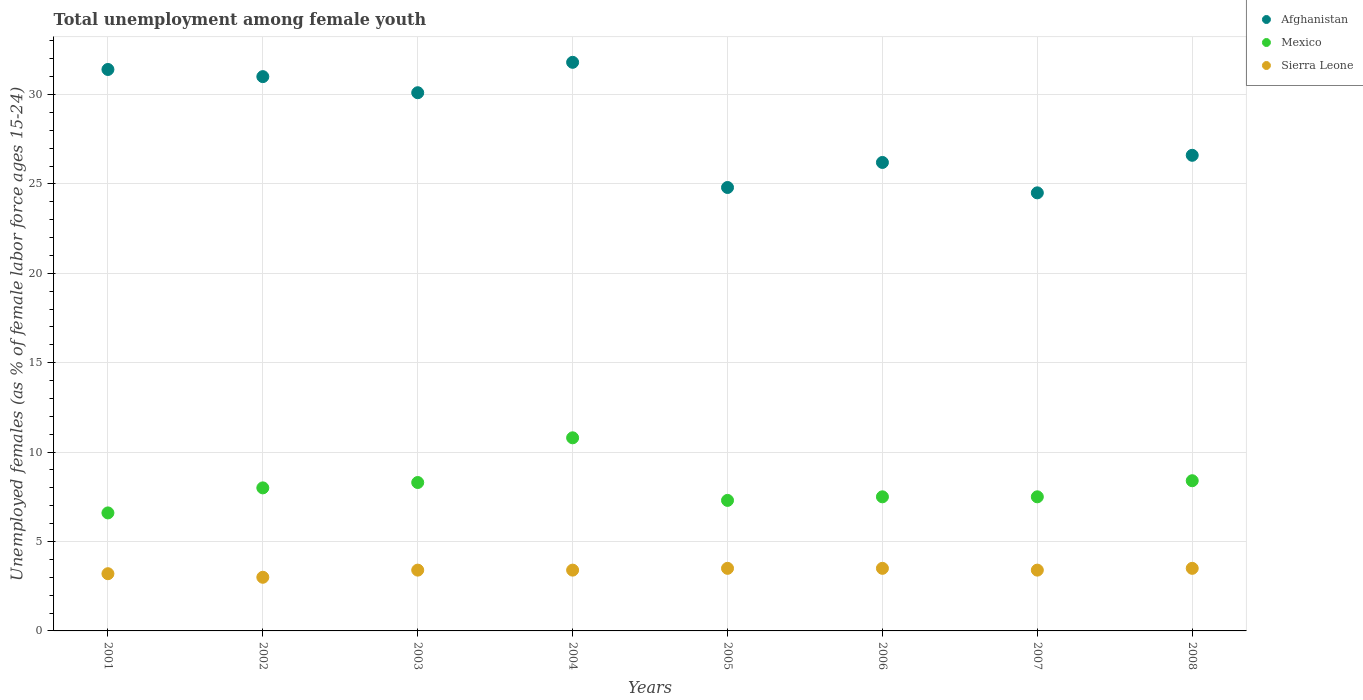Is the number of dotlines equal to the number of legend labels?
Offer a terse response. Yes. What is the percentage of unemployed females in in Sierra Leone in 2005?
Your answer should be very brief. 3.5. Across all years, what is the maximum percentage of unemployed females in in Mexico?
Make the answer very short. 10.8. Across all years, what is the minimum percentage of unemployed females in in Afghanistan?
Ensure brevity in your answer.  24.5. In which year was the percentage of unemployed females in in Sierra Leone minimum?
Make the answer very short. 2002. What is the total percentage of unemployed females in in Afghanistan in the graph?
Make the answer very short. 226.4. What is the difference between the percentage of unemployed females in in Afghanistan in 2007 and that in 2008?
Make the answer very short. -2.1. What is the difference between the percentage of unemployed females in in Mexico in 2003 and the percentage of unemployed females in in Afghanistan in 2001?
Give a very brief answer. -23.1. What is the average percentage of unemployed females in in Mexico per year?
Your answer should be very brief. 8.05. In the year 2007, what is the difference between the percentage of unemployed females in in Mexico and percentage of unemployed females in in Afghanistan?
Keep it short and to the point. -17. In how many years, is the percentage of unemployed females in in Afghanistan greater than 22 %?
Your answer should be compact. 8. What is the ratio of the percentage of unemployed females in in Afghanistan in 2004 to that in 2006?
Provide a succinct answer. 1.21. What is the difference between the highest and the second highest percentage of unemployed females in in Afghanistan?
Give a very brief answer. 0.4. What is the difference between the highest and the lowest percentage of unemployed females in in Sierra Leone?
Your response must be concise. 0.5. Is it the case that in every year, the sum of the percentage of unemployed females in in Afghanistan and percentage of unemployed females in in Sierra Leone  is greater than the percentage of unemployed females in in Mexico?
Keep it short and to the point. Yes. Does the percentage of unemployed females in in Mexico monotonically increase over the years?
Provide a succinct answer. No. Is the percentage of unemployed females in in Mexico strictly less than the percentage of unemployed females in in Afghanistan over the years?
Ensure brevity in your answer.  Yes. How many dotlines are there?
Make the answer very short. 3. How many years are there in the graph?
Make the answer very short. 8. What is the difference between two consecutive major ticks on the Y-axis?
Your answer should be compact. 5. Where does the legend appear in the graph?
Make the answer very short. Top right. How many legend labels are there?
Give a very brief answer. 3. What is the title of the graph?
Give a very brief answer. Total unemployment among female youth. What is the label or title of the X-axis?
Provide a succinct answer. Years. What is the label or title of the Y-axis?
Make the answer very short. Unemployed females (as % of female labor force ages 15-24). What is the Unemployed females (as % of female labor force ages 15-24) in Afghanistan in 2001?
Provide a short and direct response. 31.4. What is the Unemployed females (as % of female labor force ages 15-24) of Mexico in 2001?
Make the answer very short. 6.6. What is the Unemployed females (as % of female labor force ages 15-24) of Sierra Leone in 2001?
Your answer should be compact. 3.2. What is the Unemployed females (as % of female labor force ages 15-24) of Afghanistan in 2002?
Keep it short and to the point. 31. What is the Unemployed females (as % of female labor force ages 15-24) in Afghanistan in 2003?
Your answer should be compact. 30.1. What is the Unemployed females (as % of female labor force ages 15-24) in Mexico in 2003?
Offer a very short reply. 8.3. What is the Unemployed females (as % of female labor force ages 15-24) in Sierra Leone in 2003?
Offer a terse response. 3.4. What is the Unemployed females (as % of female labor force ages 15-24) of Afghanistan in 2004?
Your response must be concise. 31.8. What is the Unemployed females (as % of female labor force ages 15-24) of Mexico in 2004?
Ensure brevity in your answer.  10.8. What is the Unemployed females (as % of female labor force ages 15-24) of Sierra Leone in 2004?
Ensure brevity in your answer.  3.4. What is the Unemployed females (as % of female labor force ages 15-24) in Afghanistan in 2005?
Make the answer very short. 24.8. What is the Unemployed females (as % of female labor force ages 15-24) of Mexico in 2005?
Make the answer very short. 7.3. What is the Unemployed females (as % of female labor force ages 15-24) in Sierra Leone in 2005?
Give a very brief answer. 3.5. What is the Unemployed females (as % of female labor force ages 15-24) of Afghanistan in 2006?
Your answer should be very brief. 26.2. What is the Unemployed females (as % of female labor force ages 15-24) of Mexico in 2006?
Give a very brief answer. 7.5. What is the Unemployed females (as % of female labor force ages 15-24) of Afghanistan in 2007?
Give a very brief answer. 24.5. What is the Unemployed females (as % of female labor force ages 15-24) of Mexico in 2007?
Make the answer very short. 7.5. What is the Unemployed females (as % of female labor force ages 15-24) of Sierra Leone in 2007?
Keep it short and to the point. 3.4. What is the Unemployed females (as % of female labor force ages 15-24) of Afghanistan in 2008?
Ensure brevity in your answer.  26.6. What is the Unemployed females (as % of female labor force ages 15-24) in Mexico in 2008?
Ensure brevity in your answer.  8.4. What is the Unemployed females (as % of female labor force ages 15-24) in Sierra Leone in 2008?
Your response must be concise. 3.5. Across all years, what is the maximum Unemployed females (as % of female labor force ages 15-24) of Afghanistan?
Provide a short and direct response. 31.8. Across all years, what is the maximum Unemployed females (as % of female labor force ages 15-24) in Mexico?
Provide a succinct answer. 10.8. Across all years, what is the maximum Unemployed females (as % of female labor force ages 15-24) of Sierra Leone?
Provide a succinct answer. 3.5. Across all years, what is the minimum Unemployed females (as % of female labor force ages 15-24) of Mexico?
Your answer should be very brief. 6.6. What is the total Unemployed females (as % of female labor force ages 15-24) of Afghanistan in the graph?
Your answer should be compact. 226.4. What is the total Unemployed females (as % of female labor force ages 15-24) of Mexico in the graph?
Offer a very short reply. 64.4. What is the total Unemployed females (as % of female labor force ages 15-24) in Sierra Leone in the graph?
Provide a short and direct response. 26.9. What is the difference between the Unemployed females (as % of female labor force ages 15-24) in Mexico in 2001 and that in 2002?
Your answer should be compact. -1.4. What is the difference between the Unemployed females (as % of female labor force ages 15-24) in Sierra Leone in 2001 and that in 2002?
Provide a short and direct response. 0.2. What is the difference between the Unemployed females (as % of female labor force ages 15-24) in Afghanistan in 2001 and that in 2003?
Provide a short and direct response. 1.3. What is the difference between the Unemployed females (as % of female labor force ages 15-24) of Sierra Leone in 2001 and that in 2003?
Offer a terse response. -0.2. What is the difference between the Unemployed females (as % of female labor force ages 15-24) in Mexico in 2001 and that in 2004?
Your response must be concise. -4.2. What is the difference between the Unemployed females (as % of female labor force ages 15-24) of Mexico in 2001 and that in 2005?
Your response must be concise. -0.7. What is the difference between the Unemployed females (as % of female labor force ages 15-24) in Afghanistan in 2001 and that in 2006?
Offer a terse response. 5.2. What is the difference between the Unemployed females (as % of female labor force ages 15-24) of Mexico in 2001 and that in 2007?
Provide a succinct answer. -0.9. What is the difference between the Unemployed females (as % of female labor force ages 15-24) in Afghanistan in 2002 and that in 2003?
Offer a terse response. 0.9. What is the difference between the Unemployed females (as % of female labor force ages 15-24) in Mexico in 2002 and that in 2003?
Keep it short and to the point. -0.3. What is the difference between the Unemployed females (as % of female labor force ages 15-24) in Sierra Leone in 2002 and that in 2003?
Keep it short and to the point. -0.4. What is the difference between the Unemployed females (as % of female labor force ages 15-24) of Mexico in 2002 and that in 2004?
Your response must be concise. -2.8. What is the difference between the Unemployed females (as % of female labor force ages 15-24) in Sierra Leone in 2002 and that in 2004?
Offer a very short reply. -0.4. What is the difference between the Unemployed females (as % of female labor force ages 15-24) in Mexico in 2002 and that in 2005?
Your answer should be very brief. 0.7. What is the difference between the Unemployed females (as % of female labor force ages 15-24) in Afghanistan in 2002 and that in 2006?
Keep it short and to the point. 4.8. What is the difference between the Unemployed females (as % of female labor force ages 15-24) in Sierra Leone in 2002 and that in 2007?
Keep it short and to the point. -0.4. What is the difference between the Unemployed females (as % of female labor force ages 15-24) of Sierra Leone in 2002 and that in 2008?
Provide a succinct answer. -0.5. What is the difference between the Unemployed females (as % of female labor force ages 15-24) in Sierra Leone in 2003 and that in 2004?
Offer a terse response. 0. What is the difference between the Unemployed females (as % of female labor force ages 15-24) in Mexico in 2003 and that in 2005?
Your answer should be very brief. 1. What is the difference between the Unemployed females (as % of female labor force ages 15-24) of Afghanistan in 2003 and that in 2006?
Your answer should be very brief. 3.9. What is the difference between the Unemployed females (as % of female labor force ages 15-24) in Mexico in 2003 and that in 2006?
Your answer should be compact. 0.8. What is the difference between the Unemployed females (as % of female labor force ages 15-24) of Sierra Leone in 2003 and that in 2006?
Provide a short and direct response. -0.1. What is the difference between the Unemployed females (as % of female labor force ages 15-24) of Sierra Leone in 2003 and that in 2007?
Make the answer very short. 0. What is the difference between the Unemployed females (as % of female labor force ages 15-24) of Afghanistan in 2003 and that in 2008?
Provide a succinct answer. 3.5. What is the difference between the Unemployed females (as % of female labor force ages 15-24) of Mexico in 2003 and that in 2008?
Ensure brevity in your answer.  -0.1. What is the difference between the Unemployed females (as % of female labor force ages 15-24) in Sierra Leone in 2003 and that in 2008?
Provide a short and direct response. -0.1. What is the difference between the Unemployed females (as % of female labor force ages 15-24) of Afghanistan in 2004 and that in 2005?
Offer a very short reply. 7. What is the difference between the Unemployed females (as % of female labor force ages 15-24) of Sierra Leone in 2004 and that in 2005?
Your response must be concise. -0.1. What is the difference between the Unemployed females (as % of female labor force ages 15-24) of Mexico in 2004 and that in 2006?
Your response must be concise. 3.3. What is the difference between the Unemployed females (as % of female labor force ages 15-24) of Afghanistan in 2004 and that in 2007?
Provide a succinct answer. 7.3. What is the difference between the Unemployed females (as % of female labor force ages 15-24) of Sierra Leone in 2004 and that in 2007?
Ensure brevity in your answer.  0. What is the difference between the Unemployed females (as % of female labor force ages 15-24) in Afghanistan in 2004 and that in 2008?
Give a very brief answer. 5.2. What is the difference between the Unemployed females (as % of female labor force ages 15-24) of Afghanistan in 2005 and that in 2006?
Offer a terse response. -1.4. What is the difference between the Unemployed females (as % of female labor force ages 15-24) in Mexico in 2005 and that in 2006?
Your answer should be compact. -0.2. What is the difference between the Unemployed females (as % of female labor force ages 15-24) in Sierra Leone in 2005 and that in 2006?
Offer a very short reply. 0. What is the difference between the Unemployed females (as % of female labor force ages 15-24) in Afghanistan in 2005 and that in 2007?
Make the answer very short. 0.3. What is the difference between the Unemployed females (as % of female labor force ages 15-24) in Sierra Leone in 2005 and that in 2007?
Offer a very short reply. 0.1. What is the difference between the Unemployed females (as % of female labor force ages 15-24) of Mexico in 2005 and that in 2008?
Offer a very short reply. -1.1. What is the difference between the Unemployed females (as % of female labor force ages 15-24) of Mexico in 2006 and that in 2007?
Give a very brief answer. 0. What is the difference between the Unemployed females (as % of female labor force ages 15-24) in Sierra Leone in 2006 and that in 2007?
Provide a succinct answer. 0.1. What is the difference between the Unemployed females (as % of female labor force ages 15-24) in Afghanistan in 2007 and that in 2008?
Give a very brief answer. -2.1. What is the difference between the Unemployed females (as % of female labor force ages 15-24) of Mexico in 2007 and that in 2008?
Offer a terse response. -0.9. What is the difference between the Unemployed females (as % of female labor force ages 15-24) in Afghanistan in 2001 and the Unemployed females (as % of female labor force ages 15-24) in Mexico in 2002?
Your answer should be very brief. 23.4. What is the difference between the Unemployed females (as % of female labor force ages 15-24) in Afghanistan in 2001 and the Unemployed females (as % of female labor force ages 15-24) in Sierra Leone in 2002?
Ensure brevity in your answer.  28.4. What is the difference between the Unemployed females (as % of female labor force ages 15-24) of Afghanistan in 2001 and the Unemployed females (as % of female labor force ages 15-24) of Mexico in 2003?
Your response must be concise. 23.1. What is the difference between the Unemployed females (as % of female labor force ages 15-24) of Afghanistan in 2001 and the Unemployed females (as % of female labor force ages 15-24) of Sierra Leone in 2003?
Provide a succinct answer. 28. What is the difference between the Unemployed females (as % of female labor force ages 15-24) of Mexico in 2001 and the Unemployed females (as % of female labor force ages 15-24) of Sierra Leone in 2003?
Your answer should be compact. 3.2. What is the difference between the Unemployed females (as % of female labor force ages 15-24) in Afghanistan in 2001 and the Unemployed females (as % of female labor force ages 15-24) in Mexico in 2004?
Provide a short and direct response. 20.6. What is the difference between the Unemployed females (as % of female labor force ages 15-24) of Afghanistan in 2001 and the Unemployed females (as % of female labor force ages 15-24) of Sierra Leone in 2004?
Keep it short and to the point. 28. What is the difference between the Unemployed females (as % of female labor force ages 15-24) in Afghanistan in 2001 and the Unemployed females (as % of female labor force ages 15-24) in Mexico in 2005?
Offer a terse response. 24.1. What is the difference between the Unemployed females (as % of female labor force ages 15-24) of Afghanistan in 2001 and the Unemployed females (as % of female labor force ages 15-24) of Sierra Leone in 2005?
Provide a short and direct response. 27.9. What is the difference between the Unemployed females (as % of female labor force ages 15-24) in Mexico in 2001 and the Unemployed females (as % of female labor force ages 15-24) in Sierra Leone in 2005?
Offer a very short reply. 3.1. What is the difference between the Unemployed females (as % of female labor force ages 15-24) of Afghanistan in 2001 and the Unemployed females (as % of female labor force ages 15-24) of Mexico in 2006?
Keep it short and to the point. 23.9. What is the difference between the Unemployed females (as % of female labor force ages 15-24) of Afghanistan in 2001 and the Unemployed females (as % of female labor force ages 15-24) of Sierra Leone in 2006?
Give a very brief answer. 27.9. What is the difference between the Unemployed females (as % of female labor force ages 15-24) of Mexico in 2001 and the Unemployed females (as % of female labor force ages 15-24) of Sierra Leone in 2006?
Provide a short and direct response. 3.1. What is the difference between the Unemployed females (as % of female labor force ages 15-24) of Afghanistan in 2001 and the Unemployed females (as % of female labor force ages 15-24) of Mexico in 2007?
Your answer should be very brief. 23.9. What is the difference between the Unemployed females (as % of female labor force ages 15-24) in Afghanistan in 2001 and the Unemployed females (as % of female labor force ages 15-24) in Sierra Leone in 2007?
Keep it short and to the point. 28. What is the difference between the Unemployed females (as % of female labor force ages 15-24) of Mexico in 2001 and the Unemployed females (as % of female labor force ages 15-24) of Sierra Leone in 2007?
Offer a terse response. 3.2. What is the difference between the Unemployed females (as % of female labor force ages 15-24) of Afghanistan in 2001 and the Unemployed females (as % of female labor force ages 15-24) of Sierra Leone in 2008?
Your answer should be very brief. 27.9. What is the difference between the Unemployed females (as % of female labor force ages 15-24) in Afghanistan in 2002 and the Unemployed females (as % of female labor force ages 15-24) in Mexico in 2003?
Your answer should be very brief. 22.7. What is the difference between the Unemployed females (as % of female labor force ages 15-24) in Afghanistan in 2002 and the Unemployed females (as % of female labor force ages 15-24) in Sierra Leone in 2003?
Your response must be concise. 27.6. What is the difference between the Unemployed females (as % of female labor force ages 15-24) in Mexico in 2002 and the Unemployed females (as % of female labor force ages 15-24) in Sierra Leone in 2003?
Your answer should be compact. 4.6. What is the difference between the Unemployed females (as % of female labor force ages 15-24) in Afghanistan in 2002 and the Unemployed females (as % of female labor force ages 15-24) in Mexico in 2004?
Keep it short and to the point. 20.2. What is the difference between the Unemployed females (as % of female labor force ages 15-24) in Afghanistan in 2002 and the Unemployed females (as % of female labor force ages 15-24) in Sierra Leone in 2004?
Ensure brevity in your answer.  27.6. What is the difference between the Unemployed females (as % of female labor force ages 15-24) in Afghanistan in 2002 and the Unemployed females (as % of female labor force ages 15-24) in Mexico in 2005?
Provide a succinct answer. 23.7. What is the difference between the Unemployed females (as % of female labor force ages 15-24) of Afghanistan in 2002 and the Unemployed females (as % of female labor force ages 15-24) of Sierra Leone in 2005?
Your response must be concise. 27.5. What is the difference between the Unemployed females (as % of female labor force ages 15-24) in Afghanistan in 2002 and the Unemployed females (as % of female labor force ages 15-24) in Mexico in 2006?
Your answer should be very brief. 23.5. What is the difference between the Unemployed females (as % of female labor force ages 15-24) in Mexico in 2002 and the Unemployed females (as % of female labor force ages 15-24) in Sierra Leone in 2006?
Keep it short and to the point. 4.5. What is the difference between the Unemployed females (as % of female labor force ages 15-24) in Afghanistan in 2002 and the Unemployed females (as % of female labor force ages 15-24) in Mexico in 2007?
Your answer should be very brief. 23.5. What is the difference between the Unemployed females (as % of female labor force ages 15-24) of Afghanistan in 2002 and the Unemployed females (as % of female labor force ages 15-24) of Sierra Leone in 2007?
Your answer should be compact. 27.6. What is the difference between the Unemployed females (as % of female labor force ages 15-24) in Mexico in 2002 and the Unemployed females (as % of female labor force ages 15-24) in Sierra Leone in 2007?
Make the answer very short. 4.6. What is the difference between the Unemployed females (as % of female labor force ages 15-24) of Afghanistan in 2002 and the Unemployed females (as % of female labor force ages 15-24) of Mexico in 2008?
Provide a succinct answer. 22.6. What is the difference between the Unemployed females (as % of female labor force ages 15-24) of Afghanistan in 2002 and the Unemployed females (as % of female labor force ages 15-24) of Sierra Leone in 2008?
Your answer should be compact. 27.5. What is the difference between the Unemployed females (as % of female labor force ages 15-24) of Afghanistan in 2003 and the Unemployed females (as % of female labor force ages 15-24) of Mexico in 2004?
Offer a very short reply. 19.3. What is the difference between the Unemployed females (as % of female labor force ages 15-24) in Afghanistan in 2003 and the Unemployed females (as % of female labor force ages 15-24) in Sierra Leone in 2004?
Your answer should be compact. 26.7. What is the difference between the Unemployed females (as % of female labor force ages 15-24) of Mexico in 2003 and the Unemployed females (as % of female labor force ages 15-24) of Sierra Leone in 2004?
Provide a succinct answer. 4.9. What is the difference between the Unemployed females (as % of female labor force ages 15-24) of Afghanistan in 2003 and the Unemployed females (as % of female labor force ages 15-24) of Mexico in 2005?
Make the answer very short. 22.8. What is the difference between the Unemployed females (as % of female labor force ages 15-24) of Afghanistan in 2003 and the Unemployed females (as % of female labor force ages 15-24) of Sierra Leone in 2005?
Provide a succinct answer. 26.6. What is the difference between the Unemployed females (as % of female labor force ages 15-24) in Afghanistan in 2003 and the Unemployed females (as % of female labor force ages 15-24) in Mexico in 2006?
Offer a very short reply. 22.6. What is the difference between the Unemployed females (as % of female labor force ages 15-24) of Afghanistan in 2003 and the Unemployed females (as % of female labor force ages 15-24) of Sierra Leone in 2006?
Your response must be concise. 26.6. What is the difference between the Unemployed females (as % of female labor force ages 15-24) of Afghanistan in 2003 and the Unemployed females (as % of female labor force ages 15-24) of Mexico in 2007?
Make the answer very short. 22.6. What is the difference between the Unemployed females (as % of female labor force ages 15-24) of Afghanistan in 2003 and the Unemployed females (as % of female labor force ages 15-24) of Sierra Leone in 2007?
Offer a very short reply. 26.7. What is the difference between the Unemployed females (as % of female labor force ages 15-24) in Mexico in 2003 and the Unemployed females (as % of female labor force ages 15-24) in Sierra Leone in 2007?
Make the answer very short. 4.9. What is the difference between the Unemployed females (as % of female labor force ages 15-24) of Afghanistan in 2003 and the Unemployed females (as % of female labor force ages 15-24) of Mexico in 2008?
Provide a short and direct response. 21.7. What is the difference between the Unemployed females (as % of female labor force ages 15-24) in Afghanistan in 2003 and the Unemployed females (as % of female labor force ages 15-24) in Sierra Leone in 2008?
Offer a very short reply. 26.6. What is the difference between the Unemployed females (as % of female labor force ages 15-24) of Afghanistan in 2004 and the Unemployed females (as % of female labor force ages 15-24) of Mexico in 2005?
Offer a very short reply. 24.5. What is the difference between the Unemployed females (as % of female labor force ages 15-24) of Afghanistan in 2004 and the Unemployed females (as % of female labor force ages 15-24) of Sierra Leone in 2005?
Keep it short and to the point. 28.3. What is the difference between the Unemployed females (as % of female labor force ages 15-24) of Mexico in 2004 and the Unemployed females (as % of female labor force ages 15-24) of Sierra Leone in 2005?
Ensure brevity in your answer.  7.3. What is the difference between the Unemployed females (as % of female labor force ages 15-24) in Afghanistan in 2004 and the Unemployed females (as % of female labor force ages 15-24) in Mexico in 2006?
Offer a very short reply. 24.3. What is the difference between the Unemployed females (as % of female labor force ages 15-24) of Afghanistan in 2004 and the Unemployed females (as % of female labor force ages 15-24) of Sierra Leone in 2006?
Keep it short and to the point. 28.3. What is the difference between the Unemployed females (as % of female labor force ages 15-24) in Afghanistan in 2004 and the Unemployed females (as % of female labor force ages 15-24) in Mexico in 2007?
Offer a very short reply. 24.3. What is the difference between the Unemployed females (as % of female labor force ages 15-24) of Afghanistan in 2004 and the Unemployed females (as % of female labor force ages 15-24) of Sierra Leone in 2007?
Your answer should be very brief. 28.4. What is the difference between the Unemployed females (as % of female labor force ages 15-24) of Afghanistan in 2004 and the Unemployed females (as % of female labor force ages 15-24) of Mexico in 2008?
Keep it short and to the point. 23.4. What is the difference between the Unemployed females (as % of female labor force ages 15-24) in Afghanistan in 2004 and the Unemployed females (as % of female labor force ages 15-24) in Sierra Leone in 2008?
Give a very brief answer. 28.3. What is the difference between the Unemployed females (as % of female labor force ages 15-24) in Mexico in 2004 and the Unemployed females (as % of female labor force ages 15-24) in Sierra Leone in 2008?
Keep it short and to the point. 7.3. What is the difference between the Unemployed females (as % of female labor force ages 15-24) in Afghanistan in 2005 and the Unemployed females (as % of female labor force ages 15-24) in Mexico in 2006?
Your answer should be compact. 17.3. What is the difference between the Unemployed females (as % of female labor force ages 15-24) in Afghanistan in 2005 and the Unemployed females (as % of female labor force ages 15-24) in Sierra Leone in 2006?
Give a very brief answer. 21.3. What is the difference between the Unemployed females (as % of female labor force ages 15-24) of Mexico in 2005 and the Unemployed females (as % of female labor force ages 15-24) of Sierra Leone in 2006?
Provide a succinct answer. 3.8. What is the difference between the Unemployed females (as % of female labor force ages 15-24) of Afghanistan in 2005 and the Unemployed females (as % of female labor force ages 15-24) of Mexico in 2007?
Your response must be concise. 17.3. What is the difference between the Unemployed females (as % of female labor force ages 15-24) of Afghanistan in 2005 and the Unemployed females (as % of female labor force ages 15-24) of Sierra Leone in 2007?
Make the answer very short. 21.4. What is the difference between the Unemployed females (as % of female labor force ages 15-24) in Mexico in 2005 and the Unemployed females (as % of female labor force ages 15-24) in Sierra Leone in 2007?
Provide a succinct answer. 3.9. What is the difference between the Unemployed females (as % of female labor force ages 15-24) in Afghanistan in 2005 and the Unemployed females (as % of female labor force ages 15-24) in Mexico in 2008?
Your answer should be very brief. 16.4. What is the difference between the Unemployed females (as % of female labor force ages 15-24) in Afghanistan in 2005 and the Unemployed females (as % of female labor force ages 15-24) in Sierra Leone in 2008?
Your answer should be very brief. 21.3. What is the difference between the Unemployed females (as % of female labor force ages 15-24) of Afghanistan in 2006 and the Unemployed females (as % of female labor force ages 15-24) of Sierra Leone in 2007?
Offer a terse response. 22.8. What is the difference between the Unemployed females (as % of female labor force ages 15-24) of Afghanistan in 2006 and the Unemployed females (as % of female labor force ages 15-24) of Mexico in 2008?
Ensure brevity in your answer.  17.8. What is the difference between the Unemployed females (as % of female labor force ages 15-24) of Afghanistan in 2006 and the Unemployed females (as % of female labor force ages 15-24) of Sierra Leone in 2008?
Provide a short and direct response. 22.7. What is the difference between the Unemployed females (as % of female labor force ages 15-24) in Mexico in 2006 and the Unemployed females (as % of female labor force ages 15-24) in Sierra Leone in 2008?
Give a very brief answer. 4. What is the average Unemployed females (as % of female labor force ages 15-24) in Afghanistan per year?
Ensure brevity in your answer.  28.3. What is the average Unemployed females (as % of female labor force ages 15-24) of Mexico per year?
Give a very brief answer. 8.05. What is the average Unemployed females (as % of female labor force ages 15-24) of Sierra Leone per year?
Make the answer very short. 3.36. In the year 2001, what is the difference between the Unemployed females (as % of female labor force ages 15-24) in Afghanistan and Unemployed females (as % of female labor force ages 15-24) in Mexico?
Give a very brief answer. 24.8. In the year 2001, what is the difference between the Unemployed females (as % of female labor force ages 15-24) in Afghanistan and Unemployed females (as % of female labor force ages 15-24) in Sierra Leone?
Offer a very short reply. 28.2. In the year 2001, what is the difference between the Unemployed females (as % of female labor force ages 15-24) in Mexico and Unemployed females (as % of female labor force ages 15-24) in Sierra Leone?
Your answer should be very brief. 3.4. In the year 2002, what is the difference between the Unemployed females (as % of female labor force ages 15-24) of Afghanistan and Unemployed females (as % of female labor force ages 15-24) of Mexico?
Offer a terse response. 23. In the year 2003, what is the difference between the Unemployed females (as % of female labor force ages 15-24) in Afghanistan and Unemployed females (as % of female labor force ages 15-24) in Mexico?
Make the answer very short. 21.8. In the year 2003, what is the difference between the Unemployed females (as % of female labor force ages 15-24) in Afghanistan and Unemployed females (as % of female labor force ages 15-24) in Sierra Leone?
Give a very brief answer. 26.7. In the year 2003, what is the difference between the Unemployed females (as % of female labor force ages 15-24) in Mexico and Unemployed females (as % of female labor force ages 15-24) in Sierra Leone?
Give a very brief answer. 4.9. In the year 2004, what is the difference between the Unemployed females (as % of female labor force ages 15-24) in Afghanistan and Unemployed females (as % of female labor force ages 15-24) in Mexico?
Provide a succinct answer. 21. In the year 2004, what is the difference between the Unemployed females (as % of female labor force ages 15-24) in Afghanistan and Unemployed females (as % of female labor force ages 15-24) in Sierra Leone?
Your response must be concise. 28.4. In the year 2005, what is the difference between the Unemployed females (as % of female labor force ages 15-24) in Afghanistan and Unemployed females (as % of female labor force ages 15-24) in Sierra Leone?
Offer a terse response. 21.3. In the year 2005, what is the difference between the Unemployed females (as % of female labor force ages 15-24) of Mexico and Unemployed females (as % of female labor force ages 15-24) of Sierra Leone?
Make the answer very short. 3.8. In the year 2006, what is the difference between the Unemployed females (as % of female labor force ages 15-24) in Afghanistan and Unemployed females (as % of female labor force ages 15-24) in Sierra Leone?
Your answer should be compact. 22.7. In the year 2007, what is the difference between the Unemployed females (as % of female labor force ages 15-24) of Afghanistan and Unemployed females (as % of female labor force ages 15-24) of Sierra Leone?
Your answer should be compact. 21.1. In the year 2007, what is the difference between the Unemployed females (as % of female labor force ages 15-24) of Mexico and Unemployed females (as % of female labor force ages 15-24) of Sierra Leone?
Your answer should be very brief. 4.1. In the year 2008, what is the difference between the Unemployed females (as % of female labor force ages 15-24) of Afghanistan and Unemployed females (as % of female labor force ages 15-24) of Mexico?
Your answer should be very brief. 18.2. In the year 2008, what is the difference between the Unemployed females (as % of female labor force ages 15-24) in Afghanistan and Unemployed females (as % of female labor force ages 15-24) in Sierra Leone?
Offer a very short reply. 23.1. In the year 2008, what is the difference between the Unemployed females (as % of female labor force ages 15-24) in Mexico and Unemployed females (as % of female labor force ages 15-24) in Sierra Leone?
Offer a very short reply. 4.9. What is the ratio of the Unemployed females (as % of female labor force ages 15-24) of Afghanistan in 2001 to that in 2002?
Offer a very short reply. 1.01. What is the ratio of the Unemployed females (as % of female labor force ages 15-24) in Mexico in 2001 to that in 2002?
Offer a very short reply. 0.82. What is the ratio of the Unemployed females (as % of female labor force ages 15-24) in Sierra Leone in 2001 to that in 2002?
Offer a terse response. 1.07. What is the ratio of the Unemployed females (as % of female labor force ages 15-24) in Afghanistan in 2001 to that in 2003?
Make the answer very short. 1.04. What is the ratio of the Unemployed females (as % of female labor force ages 15-24) of Mexico in 2001 to that in 2003?
Provide a succinct answer. 0.8. What is the ratio of the Unemployed females (as % of female labor force ages 15-24) of Afghanistan in 2001 to that in 2004?
Your answer should be very brief. 0.99. What is the ratio of the Unemployed females (as % of female labor force ages 15-24) of Mexico in 2001 to that in 2004?
Give a very brief answer. 0.61. What is the ratio of the Unemployed females (as % of female labor force ages 15-24) of Sierra Leone in 2001 to that in 2004?
Ensure brevity in your answer.  0.94. What is the ratio of the Unemployed females (as % of female labor force ages 15-24) of Afghanistan in 2001 to that in 2005?
Give a very brief answer. 1.27. What is the ratio of the Unemployed females (as % of female labor force ages 15-24) in Mexico in 2001 to that in 2005?
Offer a very short reply. 0.9. What is the ratio of the Unemployed females (as % of female labor force ages 15-24) of Sierra Leone in 2001 to that in 2005?
Keep it short and to the point. 0.91. What is the ratio of the Unemployed females (as % of female labor force ages 15-24) in Afghanistan in 2001 to that in 2006?
Provide a short and direct response. 1.2. What is the ratio of the Unemployed females (as % of female labor force ages 15-24) in Sierra Leone in 2001 to that in 2006?
Ensure brevity in your answer.  0.91. What is the ratio of the Unemployed females (as % of female labor force ages 15-24) of Afghanistan in 2001 to that in 2007?
Provide a short and direct response. 1.28. What is the ratio of the Unemployed females (as % of female labor force ages 15-24) in Mexico in 2001 to that in 2007?
Keep it short and to the point. 0.88. What is the ratio of the Unemployed females (as % of female labor force ages 15-24) in Afghanistan in 2001 to that in 2008?
Offer a very short reply. 1.18. What is the ratio of the Unemployed females (as % of female labor force ages 15-24) in Mexico in 2001 to that in 2008?
Offer a very short reply. 0.79. What is the ratio of the Unemployed females (as % of female labor force ages 15-24) in Sierra Leone in 2001 to that in 2008?
Ensure brevity in your answer.  0.91. What is the ratio of the Unemployed females (as % of female labor force ages 15-24) in Afghanistan in 2002 to that in 2003?
Your answer should be very brief. 1.03. What is the ratio of the Unemployed females (as % of female labor force ages 15-24) in Mexico in 2002 to that in 2003?
Provide a short and direct response. 0.96. What is the ratio of the Unemployed females (as % of female labor force ages 15-24) of Sierra Leone in 2002 to that in 2003?
Your answer should be compact. 0.88. What is the ratio of the Unemployed females (as % of female labor force ages 15-24) of Afghanistan in 2002 to that in 2004?
Provide a succinct answer. 0.97. What is the ratio of the Unemployed females (as % of female labor force ages 15-24) of Mexico in 2002 to that in 2004?
Offer a very short reply. 0.74. What is the ratio of the Unemployed females (as % of female labor force ages 15-24) in Sierra Leone in 2002 to that in 2004?
Give a very brief answer. 0.88. What is the ratio of the Unemployed females (as % of female labor force ages 15-24) of Afghanistan in 2002 to that in 2005?
Keep it short and to the point. 1.25. What is the ratio of the Unemployed females (as % of female labor force ages 15-24) in Mexico in 2002 to that in 2005?
Provide a short and direct response. 1.1. What is the ratio of the Unemployed females (as % of female labor force ages 15-24) in Sierra Leone in 2002 to that in 2005?
Make the answer very short. 0.86. What is the ratio of the Unemployed females (as % of female labor force ages 15-24) in Afghanistan in 2002 to that in 2006?
Your answer should be compact. 1.18. What is the ratio of the Unemployed females (as % of female labor force ages 15-24) of Mexico in 2002 to that in 2006?
Offer a very short reply. 1.07. What is the ratio of the Unemployed females (as % of female labor force ages 15-24) in Afghanistan in 2002 to that in 2007?
Ensure brevity in your answer.  1.27. What is the ratio of the Unemployed females (as % of female labor force ages 15-24) in Mexico in 2002 to that in 2007?
Offer a terse response. 1.07. What is the ratio of the Unemployed females (as % of female labor force ages 15-24) of Sierra Leone in 2002 to that in 2007?
Your response must be concise. 0.88. What is the ratio of the Unemployed females (as % of female labor force ages 15-24) of Afghanistan in 2002 to that in 2008?
Provide a succinct answer. 1.17. What is the ratio of the Unemployed females (as % of female labor force ages 15-24) of Mexico in 2002 to that in 2008?
Your answer should be compact. 0.95. What is the ratio of the Unemployed females (as % of female labor force ages 15-24) in Sierra Leone in 2002 to that in 2008?
Your answer should be compact. 0.86. What is the ratio of the Unemployed females (as % of female labor force ages 15-24) in Afghanistan in 2003 to that in 2004?
Make the answer very short. 0.95. What is the ratio of the Unemployed females (as % of female labor force ages 15-24) of Mexico in 2003 to that in 2004?
Provide a short and direct response. 0.77. What is the ratio of the Unemployed females (as % of female labor force ages 15-24) of Afghanistan in 2003 to that in 2005?
Provide a short and direct response. 1.21. What is the ratio of the Unemployed females (as % of female labor force ages 15-24) of Mexico in 2003 to that in 2005?
Ensure brevity in your answer.  1.14. What is the ratio of the Unemployed females (as % of female labor force ages 15-24) in Sierra Leone in 2003 to that in 2005?
Offer a very short reply. 0.97. What is the ratio of the Unemployed females (as % of female labor force ages 15-24) in Afghanistan in 2003 to that in 2006?
Your answer should be very brief. 1.15. What is the ratio of the Unemployed females (as % of female labor force ages 15-24) of Mexico in 2003 to that in 2006?
Provide a short and direct response. 1.11. What is the ratio of the Unemployed females (as % of female labor force ages 15-24) of Sierra Leone in 2003 to that in 2006?
Give a very brief answer. 0.97. What is the ratio of the Unemployed females (as % of female labor force ages 15-24) in Afghanistan in 2003 to that in 2007?
Your answer should be compact. 1.23. What is the ratio of the Unemployed females (as % of female labor force ages 15-24) of Mexico in 2003 to that in 2007?
Your response must be concise. 1.11. What is the ratio of the Unemployed females (as % of female labor force ages 15-24) in Afghanistan in 2003 to that in 2008?
Keep it short and to the point. 1.13. What is the ratio of the Unemployed females (as % of female labor force ages 15-24) in Mexico in 2003 to that in 2008?
Offer a very short reply. 0.99. What is the ratio of the Unemployed females (as % of female labor force ages 15-24) in Sierra Leone in 2003 to that in 2008?
Ensure brevity in your answer.  0.97. What is the ratio of the Unemployed females (as % of female labor force ages 15-24) in Afghanistan in 2004 to that in 2005?
Offer a very short reply. 1.28. What is the ratio of the Unemployed females (as % of female labor force ages 15-24) of Mexico in 2004 to that in 2005?
Offer a very short reply. 1.48. What is the ratio of the Unemployed females (as % of female labor force ages 15-24) of Sierra Leone in 2004 to that in 2005?
Give a very brief answer. 0.97. What is the ratio of the Unemployed females (as % of female labor force ages 15-24) in Afghanistan in 2004 to that in 2006?
Ensure brevity in your answer.  1.21. What is the ratio of the Unemployed females (as % of female labor force ages 15-24) in Mexico in 2004 to that in 2006?
Give a very brief answer. 1.44. What is the ratio of the Unemployed females (as % of female labor force ages 15-24) of Sierra Leone in 2004 to that in 2006?
Your answer should be compact. 0.97. What is the ratio of the Unemployed females (as % of female labor force ages 15-24) of Afghanistan in 2004 to that in 2007?
Ensure brevity in your answer.  1.3. What is the ratio of the Unemployed females (as % of female labor force ages 15-24) in Mexico in 2004 to that in 2007?
Ensure brevity in your answer.  1.44. What is the ratio of the Unemployed females (as % of female labor force ages 15-24) of Afghanistan in 2004 to that in 2008?
Offer a very short reply. 1.2. What is the ratio of the Unemployed females (as % of female labor force ages 15-24) of Sierra Leone in 2004 to that in 2008?
Make the answer very short. 0.97. What is the ratio of the Unemployed females (as % of female labor force ages 15-24) in Afghanistan in 2005 to that in 2006?
Keep it short and to the point. 0.95. What is the ratio of the Unemployed females (as % of female labor force ages 15-24) of Mexico in 2005 to that in 2006?
Offer a very short reply. 0.97. What is the ratio of the Unemployed females (as % of female labor force ages 15-24) of Sierra Leone in 2005 to that in 2006?
Offer a terse response. 1. What is the ratio of the Unemployed females (as % of female labor force ages 15-24) in Afghanistan in 2005 to that in 2007?
Give a very brief answer. 1.01. What is the ratio of the Unemployed females (as % of female labor force ages 15-24) of Mexico in 2005 to that in 2007?
Your response must be concise. 0.97. What is the ratio of the Unemployed females (as % of female labor force ages 15-24) in Sierra Leone in 2005 to that in 2007?
Your answer should be very brief. 1.03. What is the ratio of the Unemployed females (as % of female labor force ages 15-24) of Afghanistan in 2005 to that in 2008?
Offer a terse response. 0.93. What is the ratio of the Unemployed females (as % of female labor force ages 15-24) of Mexico in 2005 to that in 2008?
Your response must be concise. 0.87. What is the ratio of the Unemployed females (as % of female labor force ages 15-24) in Afghanistan in 2006 to that in 2007?
Your response must be concise. 1.07. What is the ratio of the Unemployed females (as % of female labor force ages 15-24) in Sierra Leone in 2006 to that in 2007?
Offer a very short reply. 1.03. What is the ratio of the Unemployed females (as % of female labor force ages 15-24) in Mexico in 2006 to that in 2008?
Keep it short and to the point. 0.89. What is the ratio of the Unemployed females (as % of female labor force ages 15-24) in Afghanistan in 2007 to that in 2008?
Your response must be concise. 0.92. What is the ratio of the Unemployed females (as % of female labor force ages 15-24) in Mexico in 2007 to that in 2008?
Your answer should be very brief. 0.89. What is the ratio of the Unemployed females (as % of female labor force ages 15-24) in Sierra Leone in 2007 to that in 2008?
Your answer should be compact. 0.97. What is the difference between the highest and the second highest Unemployed females (as % of female labor force ages 15-24) of Sierra Leone?
Ensure brevity in your answer.  0. What is the difference between the highest and the lowest Unemployed females (as % of female labor force ages 15-24) of Afghanistan?
Offer a terse response. 7.3. What is the difference between the highest and the lowest Unemployed females (as % of female labor force ages 15-24) in Mexico?
Provide a short and direct response. 4.2. 